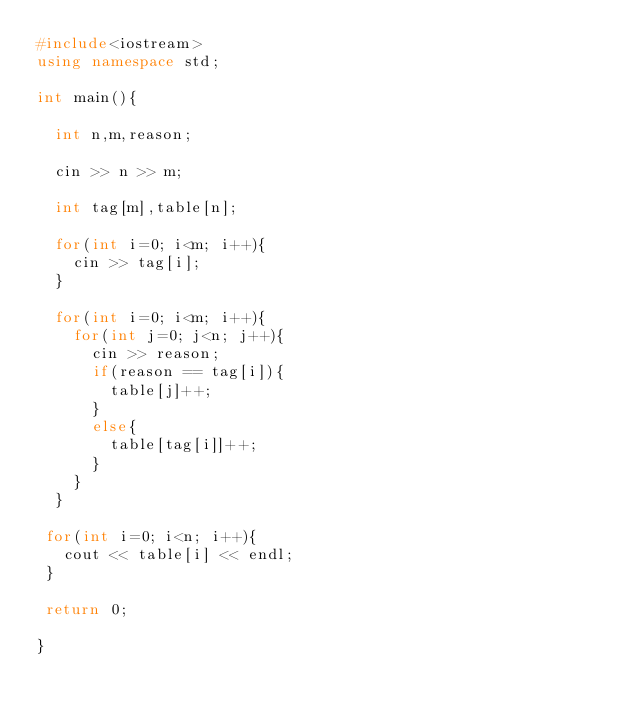Convert code to text. <code><loc_0><loc_0><loc_500><loc_500><_C++_>#include<iostream>
using namespace std;

int main(){

  int n,m,reason;

  cin >> n >> m;

  int tag[m],table[n];

  for(int i=0; i<m; i++){
    cin >> tag[i];
  }

  for(int i=0; i<m; i++){
    for(int j=0; j<n; j++){
      cin >> reason;
      if(reason == tag[i]){
        table[j]++;
      }
      else{ 
        table[tag[i]]++;
      }
    }
  }

 for(int i=0; i<n; i++){
   cout << table[i] << endl;
 }

 return 0;

}
    </code> 